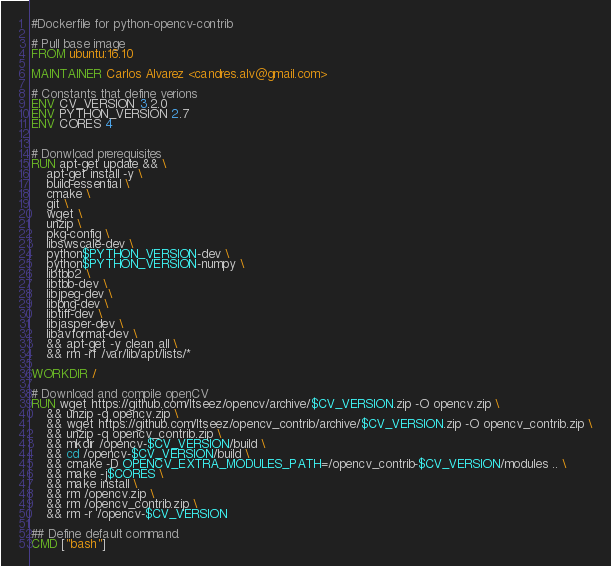<code> <loc_0><loc_0><loc_500><loc_500><_Dockerfile_>#Dockerfile for python-opencv-contrib

# Pull base image
FROM ubuntu:16.10

MAINTAINER Carlos Alvarez <candres.alv@gmail.com>

# Constants that define verions
ENV CV_VERSION 3.2.0
ENV PYTHON_VERSION 2.7
ENV CORES 4


# Donwload prerequisites
RUN apt-get update && \
    apt-get install -y \
    build-essential \
    cmake \
    git \
    wget \
    unzip \
    pkg-config \
    libswscale-dev \
    python$PYTHON_VERSION-dev \
    python$PYTHON_VERSION-numpy \
    libtbb2 \
    libtbb-dev \
    libjpeg-dev \
    libpng-dev \
    libtiff-dev \
    libjasper-dev \
    libavformat-dev \
    && apt-get -y clean all \
    && rm -rf /var/lib/apt/lists/*

WORKDIR /

# Download and compile openCV
RUN wget https://github.com/Itseez/opencv/archive/$CV_VERSION.zip -O opencv.zip \
    && unzip -q opencv.zip \
    && wget https://github.com/Itseez/opencv_contrib/archive/$CV_VERSION.zip -O opencv_contrib.zip \
    && unzip -q opencv_contrib.zip \
    && mkdir /opencv-$CV_VERSION/build \
    && cd /opencv-$CV_VERSION/build \
    && cmake -D OPENCV_EXTRA_MODULES_PATH=/opencv_contrib-$CV_VERSION/modules .. \
    && make -j$CORES \
    && make install \
    && rm /opencv.zip \
    && rm /opencv_contrib.zip \
    && rm -r /opencv-$CV_VERSION

## Define default command.
CMD ["bash"]
</code> 